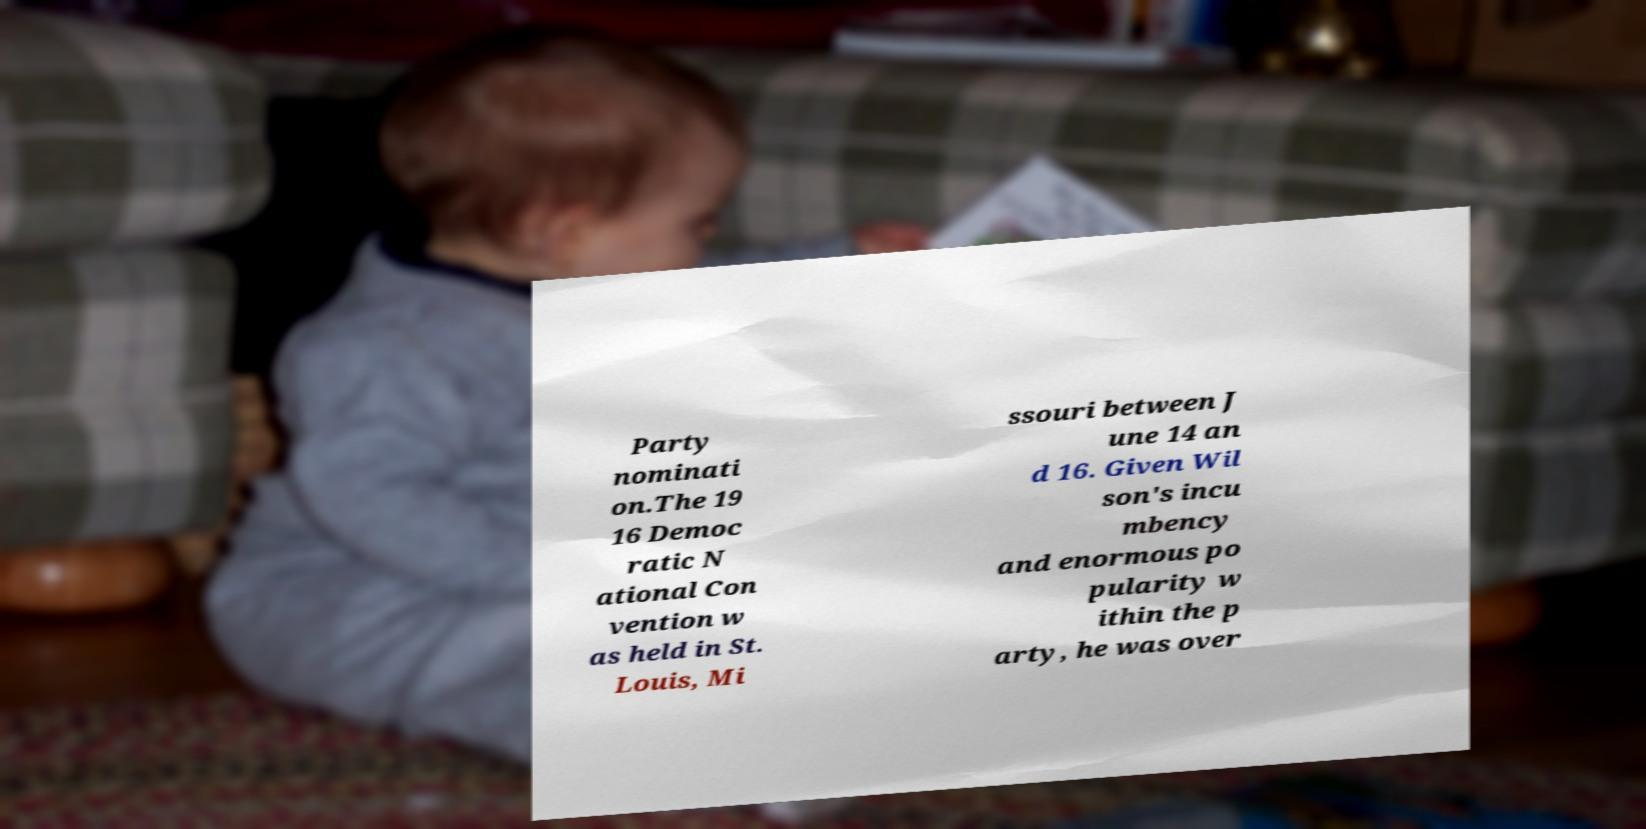For documentation purposes, I need the text within this image transcribed. Could you provide that? Party nominati on.The 19 16 Democ ratic N ational Con vention w as held in St. Louis, Mi ssouri between J une 14 an d 16. Given Wil son's incu mbency and enormous po pularity w ithin the p arty, he was over 